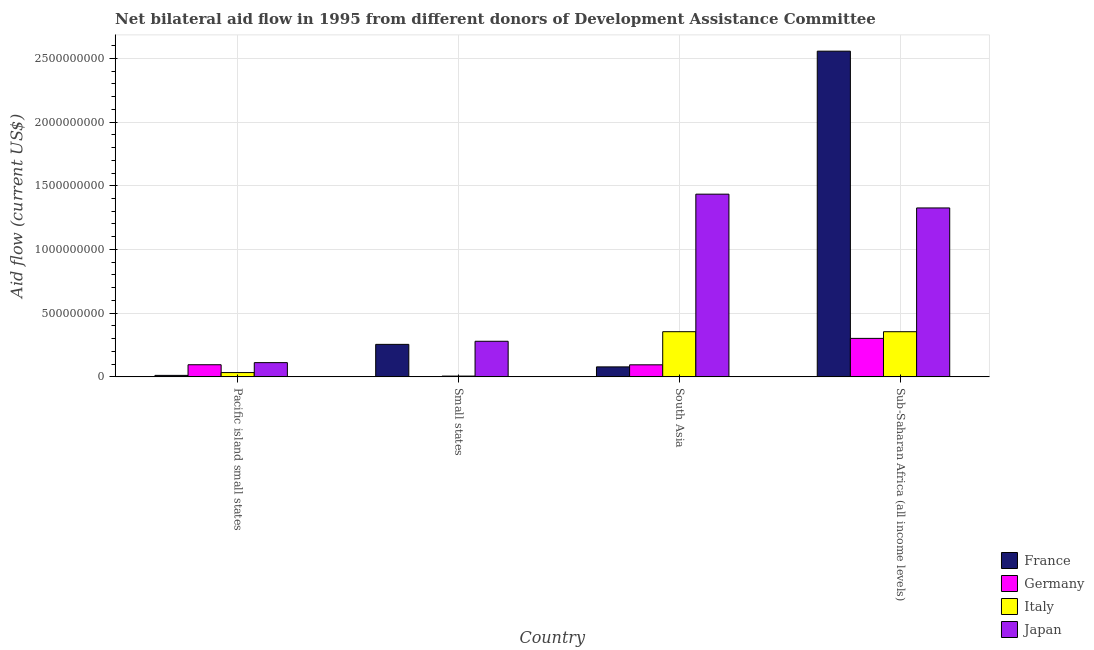How many different coloured bars are there?
Keep it short and to the point. 4. How many groups of bars are there?
Your answer should be very brief. 4. Are the number of bars on each tick of the X-axis equal?
Offer a terse response. Yes. How many bars are there on the 2nd tick from the left?
Give a very brief answer. 4. What is the label of the 4th group of bars from the left?
Give a very brief answer. Sub-Saharan Africa (all income levels). In how many cases, is the number of bars for a given country not equal to the number of legend labels?
Provide a short and direct response. 0. What is the amount of aid given by italy in South Asia?
Your response must be concise. 3.55e+08. Across all countries, what is the maximum amount of aid given by japan?
Ensure brevity in your answer.  1.43e+09. Across all countries, what is the minimum amount of aid given by japan?
Your answer should be compact. 1.12e+08. In which country was the amount of aid given by germany maximum?
Your response must be concise. Sub-Saharan Africa (all income levels). In which country was the amount of aid given by france minimum?
Offer a very short reply. Pacific island small states. What is the total amount of aid given by japan in the graph?
Offer a terse response. 3.15e+09. What is the difference between the amount of aid given by japan in Small states and that in South Asia?
Make the answer very short. -1.15e+09. What is the difference between the amount of aid given by france in Sub-Saharan Africa (all income levels) and the amount of aid given by germany in Pacific island small states?
Provide a short and direct response. 2.46e+09. What is the average amount of aid given by japan per country?
Give a very brief answer. 7.88e+08. What is the difference between the amount of aid given by japan and amount of aid given by france in Pacific island small states?
Ensure brevity in your answer.  1.00e+08. In how many countries, is the amount of aid given by germany greater than 600000000 US$?
Provide a succinct answer. 0. What is the ratio of the amount of aid given by germany in Pacific island small states to that in Sub-Saharan Africa (all income levels)?
Your response must be concise. 0.32. Is the amount of aid given by germany in Pacific island small states less than that in Sub-Saharan Africa (all income levels)?
Your answer should be very brief. Yes. Is the difference between the amount of aid given by italy in Pacific island small states and Sub-Saharan Africa (all income levels) greater than the difference between the amount of aid given by japan in Pacific island small states and Sub-Saharan Africa (all income levels)?
Your answer should be very brief. Yes. What is the difference between the highest and the second highest amount of aid given by germany?
Your response must be concise. 2.07e+08. What is the difference between the highest and the lowest amount of aid given by germany?
Provide a succinct answer. 3.01e+08. Is the sum of the amount of aid given by germany in Pacific island small states and Sub-Saharan Africa (all income levels) greater than the maximum amount of aid given by italy across all countries?
Give a very brief answer. Yes. Is it the case that in every country, the sum of the amount of aid given by japan and amount of aid given by germany is greater than the sum of amount of aid given by italy and amount of aid given by france?
Keep it short and to the point. No. What does the 1st bar from the right in Small states represents?
Offer a very short reply. Japan. Is it the case that in every country, the sum of the amount of aid given by france and amount of aid given by germany is greater than the amount of aid given by italy?
Make the answer very short. No. How many bars are there?
Your answer should be very brief. 16. Where does the legend appear in the graph?
Your response must be concise. Bottom right. How many legend labels are there?
Offer a terse response. 4. What is the title of the graph?
Your answer should be compact. Net bilateral aid flow in 1995 from different donors of Development Assistance Committee. Does "Arable land" appear as one of the legend labels in the graph?
Ensure brevity in your answer.  No. What is the Aid flow (current US$) of France in Pacific island small states?
Ensure brevity in your answer.  1.17e+07. What is the Aid flow (current US$) of Germany in Pacific island small states?
Offer a terse response. 9.52e+07. What is the Aid flow (current US$) of Italy in Pacific island small states?
Provide a succinct answer. 3.37e+07. What is the Aid flow (current US$) in Japan in Pacific island small states?
Your response must be concise. 1.12e+08. What is the Aid flow (current US$) of France in Small states?
Ensure brevity in your answer.  2.55e+08. What is the Aid flow (current US$) of Germany in Small states?
Give a very brief answer. 1.62e+06. What is the Aid flow (current US$) of Italy in Small states?
Give a very brief answer. 6.11e+06. What is the Aid flow (current US$) of Japan in Small states?
Keep it short and to the point. 2.79e+08. What is the Aid flow (current US$) in France in South Asia?
Give a very brief answer. 7.84e+07. What is the Aid flow (current US$) in Germany in South Asia?
Keep it short and to the point. 9.46e+07. What is the Aid flow (current US$) in Italy in South Asia?
Provide a succinct answer. 3.55e+08. What is the Aid flow (current US$) of Japan in South Asia?
Offer a terse response. 1.43e+09. What is the Aid flow (current US$) of France in Sub-Saharan Africa (all income levels)?
Your answer should be very brief. 2.56e+09. What is the Aid flow (current US$) of Germany in Sub-Saharan Africa (all income levels)?
Keep it short and to the point. 3.02e+08. What is the Aid flow (current US$) of Italy in Sub-Saharan Africa (all income levels)?
Keep it short and to the point. 3.54e+08. What is the Aid flow (current US$) of Japan in Sub-Saharan Africa (all income levels)?
Your answer should be compact. 1.33e+09. Across all countries, what is the maximum Aid flow (current US$) of France?
Your answer should be compact. 2.56e+09. Across all countries, what is the maximum Aid flow (current US$) of Germany?
Your answer should be very brief. 3.02e+08. Across all countries, what is the maximum Aid flow (current US$) of Italy?
Offer a terse response. 3.55e+08. Across all countries, what is the maximum Aid flow (current US$) of Japan?
Provide a short and direct response. 1.43e+09. Across all countries, what is the minimum Aid flow (current US$) of France?
Provide a succinct answer. 1.17e+07. Across all countries, what is the minimum Aid flow (current US$) in Germany?
Ensure brevity in your answer.  1.62e+06. Across all countries, what is the minimum Aid flow (current US$) in Italy?
Provide a succinct answer. 6.11e+06. Across all countries, what is the minimum Aid flow (current US$) of Japan?
Your answer should be compact. 1.12e+08. What is the total Aid flow (current US$) in France in the graph?
Give a very brief answer. 2.90e+09. What is the total Aid flow (current US$) of Germany in the graph?
Offer a very short reply. 4.94e+08. What is the total Aid flow (current US$) of Italy in the graph?
Ensure brevity in your answer.  7.49e+08. What is the total Aid flow (current US$) in Japan in the graph?
Offer a terse response. 3.15e+09. What is the difference between the Aid flow (current US$) in France in Pacific island small states and that in Small states?
Your answer should be very brief. -2.43e+08. What is the difference between the Aid flow (current US$) of Germany in Pacific island small states and that in Small states?
Give a very brief answer. 9.36e+07. What is the difference between the Aid flow (current US$) of Italy in Pacific island small states and that in Small states?
Offer a terse response. 2.76e+07. What is the difference between the Aid flow (current US$) of Japan in Pacific island small states and that in Small states?
Your answer should be very brief. -1.68e+08. What is the difference between the Aid flow (current US$) of France in Pacific island small states and that in South Asia?
Your answer should be compact. -6.67e+07. What is the difference between the Aid flow (current US$) of Italy in Pacific island small states and that in South Asia?
Ensure brevity in your answer.  -3.21e+08. What is the difference between the Aid flow (current US$) in Japan in Pacific island small states and that in South Asia?
Ensure brevity in your answer.  -1.32e+09. What is the difference between the Aid flow (current US$) of France in Pacific island small states and that in Sub-Saharan Africa (all income levels)?
Your response must be concise. -2.54e+09. What is the difference between the Aid flow (current US$) of Germany in Pacific island small states and that in Sub-Saharan Africa (all income levels)?
Keep it short and to the point. -2.07e+08. What is the difference between the Aid flow (current US$) of Italy in Pacific island small states and that in Sub-Saharan Africa (all income levels)?
Your answer should be compact. -3.21e+08. What is the difference between the Aid flow (current US$) of Japan in Pacific island small states and that in Sub-Saharan Africa (all income levels)?
Your answer should be compact. -1.21e+09. What is the difference between the Aid flow (current US$) in France in Small states and that in South Asia?
Your answer should be compact. 1.77e+08. What is the difference between the Aid flow (current US$) in Germany in Small states and that in South Asia?
Make the answer very short. -9.30e+07. What is the difference between the Aid flow (current US$) in Italy in Small states and that in South Asia?
Your answer should be compact. -3.49e+08. What is the difference between the Aid flow (current US$) in Japan in Small states and that in South Asia?
Keep it short and to the point. -1.15e+09. What is the difference between the Aid flow (current US$) in France in Small states and that in Sub-Saharan Africa (all income levels)?
Your answer should be compact. -2.30e+09. What is the difference between the Aid flow (current US$) of Germany in Small states and that in Sub-Saharan Africa (all income levels)?
Offer a terse response. -3.01e+08. What is the difference between the Aid flow (current US$) in Italy in Small states and that in Sub-Saharan Africa (all income levels)?
Ensure brevity in your answer.  -3.48e+08. What is the difference between the Aid flow (current US$) in Japan in Small states and that in Sub-Saharan Africa (all income levels)?
Provide a succinct answer. -1.05e+09. What is the difference between the Aid flow (current US$) in France in South Asia and that in Sub-Saharan Africa (all income levels)?
Make the answer very short. -2.48e+09. What is the difference between the Aid flow (current US$) in Germany in South Asia and that in Sub-Saharan Africa (all income levels)?
Provide a succinct answer. -2.08e+08. What is the difference between the Aid flow (current US$) of Italy in South Asia and that in Sub-Saharan Africa (all income levels)?
Keep it short and to the point. 1.60e+05. What is the difference between the Aid flow (current US$) in Japan in South Asia and that in Sub-Saharan Africa (all income levels)?
Offer a terse response. 1.08e+08. What is the difference between the Aid flow (current US$) of France in Pacific island small states and the Aid flow (current US$) of Germany in Small states?
Offer a very short reply. 1.00e+07. What is the difference between the Aid flow (current US$) in France in Pacific island small states and the Aid flow (current US$) in Italy in Small states?
Provide a succinct answer. 5.56e+06. What is the difference between the Aid flow (current US$) of France in Pacific island small states and the Aid flow (current US$) of Japan in Small states?
Your response must be concise. -2.68e+08. What is the difference between the Aid flow (current US$) of Germany in Pacific island small states and the Aid flow (current US$) of Italy in Small states?
Your answer should be compact. 8.91e+07. What is the difference between the Aid flow (current US$) of Germany in Pacific island small states and the Aid flow (current US$) of Japan in Small states?
Keep it short and to the point. -1.84e+08. What is the difference between the Aid flow (current US$) of Italy in Pacific island small states and the Aid flow (current US$) of Japan in Small states?
Ensure brevity in your answer.  -2.46e+08. What is the difference between the Aid flow (current US$) in France in Pacific island small states and the Aid flow (current US$) in Germany in South Asia?
Make the answer very short. -8.30e+07. What is the difference between the Aid flow (current US$) in France in Pacific island small states and the Aid flow (current US$) in Italy in South Asia?
Make the answer very short. -3.43e+08. What is the difference between the Aid flow (current US$) of France in Pacific island small states and the Aid flow (current US$) of Japan in South Asia?
Your answer should be very brief. -1.42e+09. What is the difference between the Aid flow (current US$) in Germany in Pacific island small states and the Aid flow (current US$) in Italy in South Asia?
Offer a very short reply. -2.59e+08. What is the difference between the Aid flow (current US$) of Germany in Pacific island small states and the Aid flow (current US$) of Japan in South Asia?
Your answer should be compact. -1.34e+09. What is the difference between the Aid flow (current US$) in Italy in Pacific island small states and the Aid flow (current US$) in Japan in South Asia?
Make the answer very short. -1.40e+09. What is the difference between the Aid flow (current US$) in France in Pacific island small states and the Aid flow (current US$) in Germany in Sub-Saharan Africa (all income levels)?
Your response must be concise. -2.90e+08. What is the difference between the Aid flow (current US$) of France in Pacific island small states and the Aid flow (current US$) of Italy in Sub-Saharan Africa (all income levels)?
Your answer should be very brief. -3.43e+08. What is the difference between the Aid flow (current US$) of France in Pacific island small states and the Aid flow (current US$) of Japan in Sub-Saharan Africa (all income levels)?
Make the answer very short. -1.31e+09. What is the difference between the Aid flow (current US$) in Germany in Pacific island small states and the Aid flow (current US$) in Italy in Sub-Saharan Africa (all income levels)?
Your answer should be compact. -2.59e+08. What is the difference between the Aid flow (current US$) of Germany in Pacific island small states and the Aid flow (current US$) of Japan in Sub-Saharan Africa (all income levels)?
Provide a succinct answer. -1.23e+09. What is the difference between the Aid flow (current US$) of Italy in Pacific island small states and the Aid flow (current US$) of Japan in Sub-Saharan Africa (all income levels)?
Provide a succinct answer. -1.29e+09. What is the difference between the Aid flow (current US$) of France in Small states and the Aid flow (current US$) of Germany in South Asia?
Offer a very short reply. 1.60e+08. What is the difference between the Aid flow (current US$) of France in Small states and the Aid flow (current US$) of Italy in South Asia?
Your response must be concise. -9.95e+07. What is the difference between the Aid flow (current US$) of France in Small states and the Aid flow (current US$) of Japan in South Asia?
Offer a terse response. -1.18e+09. What is the difference between the Aid flow (current US$) in Germany in Small states and the Aid flow (current US$) in Italy in South Asia?
Make the answer very short. -3.53e+08. What is the difference between the Aid flow (current US$) of Germany in Small states and the Aid flow (current US$) of Japan in South Asia?
Your answer should be very brief. -1.43e+09. What is the difference between the Aid flow (current US$) of Italy in Small states and the Aid flow (current US$) of Japan in South Asia?
Ensure brevity in your answer.  -1.43e+09. What is the difference between the Aid flow (current US$) in France in Small states and the Aid flow (current US$) in Germany in Sub-Saharan Africa (all income levels)?
Offer a very short reply. -4.70e+07. What is the difference between the Aid flow (current US$) in France in Small states and the Aid flow (current US$) in Italy in Sub-Saharan Africa (all income levels)?
Provide a short and direct response. -9.94e+07. What is the difference between the Aid flow (current US$) in France in Small states and the Aid flow (current US$) in Japan in Sub-Saharan Africa (all income levels)?
Give a very brief answer. -1.07e+09. What is the difference between the Aid flow (current US$) in Germany in Small states and the Aid flow (current US$) in Italy in Sub-Saharan Africa (all income levels)?
Your response must be concise. -3.53e+08. What is the difference between the Aid flow (current US$) in Germany in Small states and the Aid flow (current US$) in Japan in Sub-Saharan Africa (all income levels)?
Provide a short and direct response. -1.32e+09. What is the difference between the Aid flow (current US$) of Italy in Small states and the Aid flow (current US$) of Japan in Sub-Saharan Africa (all income levels)?
Provide a short and direct response. -1.32e+09. What is the difference between the Aid flow (current US$) in France in South Asia and the Aid flow (current US$) in Germany in Sub-Saharan Africa (all income levels)?
Your answer should be very brief. -2.24e+08. What is the difference between the Aid flow (current US$) in France in South Asia and the Aid flow (current US$) in Italy in Sub-Saharan Africa (all income levels)?
Offer a terse response. -2.76e+08. What is the difference between the Aid flow (current US$) in France in South Asia and the Aid flow (current US$) in Japan in Sub-Saharan Africa (all income levels)?
Your response must be concise. -1.25e+09. What is the difference between the Aid flow (current US$) in Germany in South Asia and the Aid flow (current US$) in Italy in Sub-Saharan Africa (all income levels)?
Provide a succinct answer. -2.60e+08. What is the difference between the Aid flow (current US$) in Germany in South Asia and the Aid flow (current US$) in Japan in Sub-Saharan Africa (all income levels)?
Your answer should be compact. -1.23e+09. What is the difference between the Aid flow (current US$) of Italy in South Asia and the Aid flow (current US$) of Japan in Sub-Saharan Africa (all income levels)?
Ensure brevity in your answer.  -9.71e+08. What is the average Aid flow (current US$) of France per country?
Make the answer very short. 7.25e+08. What is the average Aid flow (current US$) in Germany per country?
Provide a succinct answer. 1.23e+08. What is the average Aid flow (current US$) of Italy per country?
Provide a short and direct response. 1.87e+08. What is the average Aid flow (current US$) of Japan per country?
Your answer should be very brief. 7.88e+08. What is the difference between the Aid flow (current US$) of France and Aid flow (current US$) of Germany in Pacific island small states?
Offer a very short reply. -8.36e+07. What is the difference between the Aid flow (current US$) in France and Aid flow (current US$) in Italy in Pacific island small states?
Offer a very short reply. -2.21e+07. What is the difference between the Aid flow (current US$) of France and Aid flow (current US$) of Japan in Pacific island small states?
Make the answer very short. -1.00e+08. What is the difference between the Aid flow (current US$) of Germany and Aid flow (current US$) of Italy in Pacific island small states?
Your answer should be compact. 6.15e+07. What is the difference between the Aid flow (current US$) in Germany and Aid flow (current US$) in Japan in Pacific island small states?
Ensure brevity in your answer.  -1.66e+07. What is the difference between the Aid flow (current US$) in Italy and Aid flow (current US$) in Japan in Pacific island small states?
Your answer should be very brief. -7.81e+07. What is the difference between the Aid flow (current US$) of France and Aid flow (current US$) of Germany in Small states?
Make the answer very short. 2.53e+08. What is the difference between the Aid flow (current US$) in France and Aid flow (current US$) in Italy in Small states?
Give a very brief answer. 2.49e+08. What is the difference between the Aid flow (current US$) in France and Aid flow (current US$) in Japan in Small states?
Provide a succinct answer. -2.43e+07. What is the difference between the Aid flow (current US$) in Germany and Aid flow (current US$) in Italy in Small states?
Your answer should be compact. -4.49e+06. What is the difference between the Aid flow (current US$) of Germany and Aid flow (current US$) of Japan in Small states?
Provide a short and direct response. -2.78e+08. What is the difference between the Aid flow (current US$) of Italy and Aid flow (current US$) of Japan in Small states?
Your answer should be very brief. -2.73e+08. What is the difference between the Aid flow (current US$) in France and Aid flow (current US$) in Germany in South Asia?
Keep it short and to the point. -1.62e+07. What is the difference between the Aid flow (current US$) in France and Aid flow (current US$) in Italy in South Asia?
Provide a short and direct response. -2.76e+08. What is the difference between the Aid flow (current US$) in France and Aid flow (current US$) in Japan in South Asia?
Offer a terse response. -1.36e+09. What is the difference between the Aid flow (current US$) in Germany and Aid flow (current US$) in Italy in South Asia?
Make the answer very short. -2.60e+08. What is the difference between the Aid flow (current US$) in Germany and Aid flow (current US$) in Japan in South Asia?
Ensure brevity in your answer.  -1.34e+09. What is the difference between the Aid flow (current US$) in Italy and Aid flow (current US$) in Japan in South Asia?
Offer a terse response. -1.08e+09. What is the difference between the Aid flow (current US$) in France and Aid flow (current US$) in Germany in Sub-Saharan Africa (all income levels)?
Make the answer very short. 2.25e+09. What is the difference between the Aid flow (current US$) of France and Aid flow (current US$) of Italy in Sub-Saharan Africa (all income levels)?
Your answer should be very brief. 2.20e+09. What is the difference between the Aid flow (current US$) of France and Aid flow (current US$) of Japan in Sub-Saharan Africa (all income levels)?
Your answer should be very brief. 1.23e+09. What is the difference between the Aid flow (current US$) of Germany and Aid flow (current US$) of Italy in Sub-Saharan Africa (all income levels)?
Provide a succinct answer. -5.23e+07. What is the difference between the Aid flow (current US$) in Germany and Aid flow (current US$) in Japan in Sub-Saharan Africa (all income levels)?
Your answer should be compact. -1.02e+09. What is the difference between the Aid flow (current US$) in Italy and Aid flow (current US$) in Japan in Sub-Saharan Africa (all income levels)?
Keep it short and to the point. -9.71e+08. What is the ratio of the Aid flow (current US$) of France in Pacific island small states to that in Small states?
Provide a succinct answer. 0.05. What is the ratio of the Aid flow (current US$) in Germany in Pacific island small states to that in Small states?
Your response must be concise. 58.78. What is the ratio of the Aid flow (current US$) of Italy in Pacific island small states to that in Small states?
Make the answer very short. 5.52. What is the ratio of the Aid flow (current US$) in Japan in Pacific island small states to that in Small states?
Provide a succinct answer. 0.4. What is the ratio of the Aid flow (current US$) of France in Pacific island small states to that in South Asia?
Provide a succinct answer. 0.15. What is the ratio of the Aid flow (current US$) in Germany in Pacific island small states to that in South Asia?
Your response must be concise. 1.01. What is the ratio of the Aid flow (current US$) of Italy in Pacific island small states to that in South Asia?
Provide a succinct answer. 0.1. What is the ratio of the Aid flow (current US$) of Japan in Pacific island small states to that in South Asia?
Give a very brief answer. 0.08. What is the ratio of the Aid flow (current US$) in France in Pacific island small states to that in Sub-Saharan Africa (all income levels)?
Offer a terse response. 0. What is the ratio of the Aid flow (current US$) in Germany in Pacific island small states to that in Sub-Saharan Africa (all income levels)?
Offer a very short reply. 0.32. What is the ratio of the Aid flow (current US$) of Italy in Pacific island small states to that in Sub-Saharan Africa (all income levels)?
Provide a succinct answer. 0.1. What is the ratio of the Aid flow (current US$) of Japan in Pacific island small states to that in Sub-Saharan Africa (all income levels)?
Ensure brevity in your answer.  0.08. What is the ratio of the Aid flow (current US$) of France in Small states to that in South Asia?
Provide a succinct answer. 3.25. What is the ratio of the Aid flow (current US$) of Germany in Small states to that in South Asia?
Your answer should be compact. 0.02. What is the ratio of the Aid flow (current US$) in Italy in Small states to that in South Asia?
Provide a succinct answer. 0.02. What is the ratio of the Aid flow (current US$) in Japan in Small states to that in South Asia?
Keep it short and to the point. 0.19. What is the ratio of the Aid flow (current US$) in France in Small states to that in Sub-Saharan Africa (all income levels)?
Offer a very short reply. 0.1. What is the ratio of the Aid flow (current US$) of Germany in Small states to that in Sub-Saharan Africa (all income levels)?
Provide a succinct answer. 0.01. What is the ratio of the Aid flow (current US$) in Italy in Small states to that in Sub-Saharan Africa (all income levels)?
Give a very brief answer. 0.02. What is the ratio of the Aid flow (current US$) in Japan in Small states to that in Sub-Saharan Africa (all income levels)?
Make the answer very short. 0.21. What is the ratio of the Aid flow (current US$) of France in South Asia to that in Sub-Saharan Africa (all income levels)?
Offer a terse response. 0.03. What is the ratio of the Aid flow (current US$) of Germany in South Asia to that in Sub-Saharan Africa (all income levels)?
Keep it short and to the point. 0.31. What is the ratio of the Aid flow (current US$) in Japan in South Asia to that in Sub-Saharan Africa (all income levels)?
Provide a succinct answer. 1.08. What is the difference between the highest and the second highest Aid flow (current US$) in France?
Offer a terse response. 2.30e+09. What is the difference between the highest and the second highest Aid flow (current US$) in Germany?
Offer a terse response. 2.07e+08. What is the difference between the highest and the second highest Aid flow (current US$) in Italy?
Make the answer very short. 1.60e+05. What is the difference between the highest and the second highest Aid flow (current US$) in Japan?
Make the answer very short. 1.08e+08. What is the difference between the highest and the lowest Aid flow (current US$) of France?
Give a very brief answer. 2.54e+09. What is the difference between the highest and the lowest Aid flow (current US$) in Germany?
Your answer should be very brief. 3.01e+08. What is the difference between the highest and the lowest Aid flow (current US$) in Italy?
Your response must be concise. 3.49e+08. What is the difference between the highest and the lowest Aid flow (current US$) in Japan?
Give a very brief answer. 1.32e+09. 